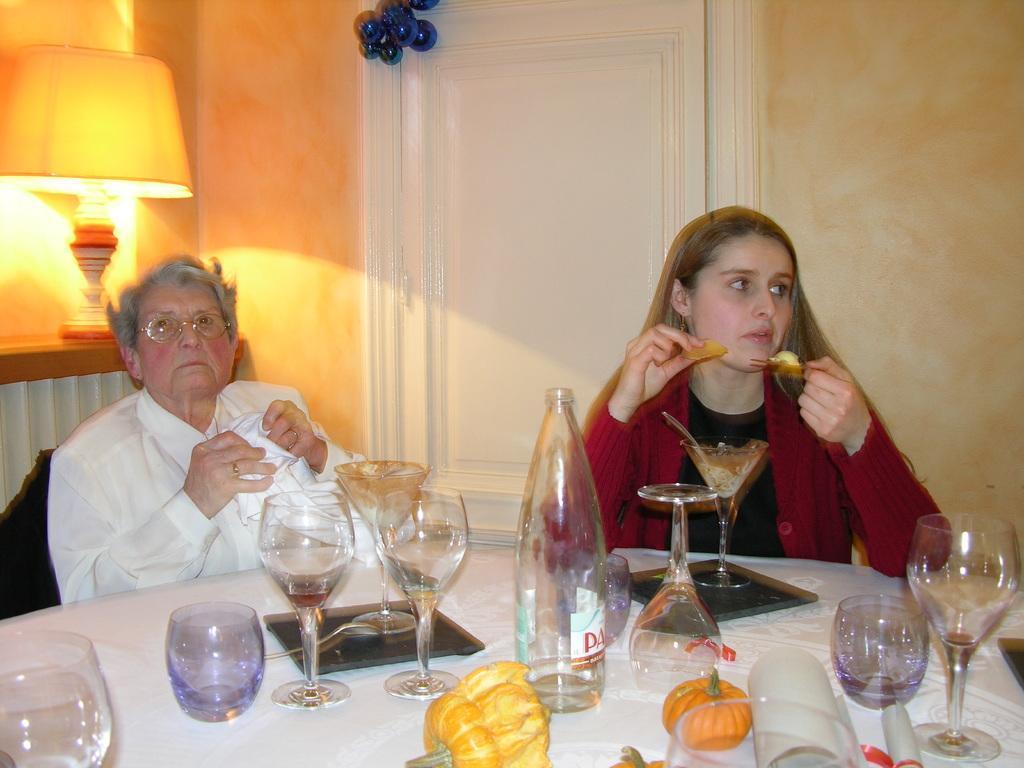In one or two sentences, can you explain what this image depicts? In this image, we can see two people are holding some objects. At the bottom, there is a white cloth. Few things and objects are placed on it. Background we can see a wall, door, lamp, decorative piece. 